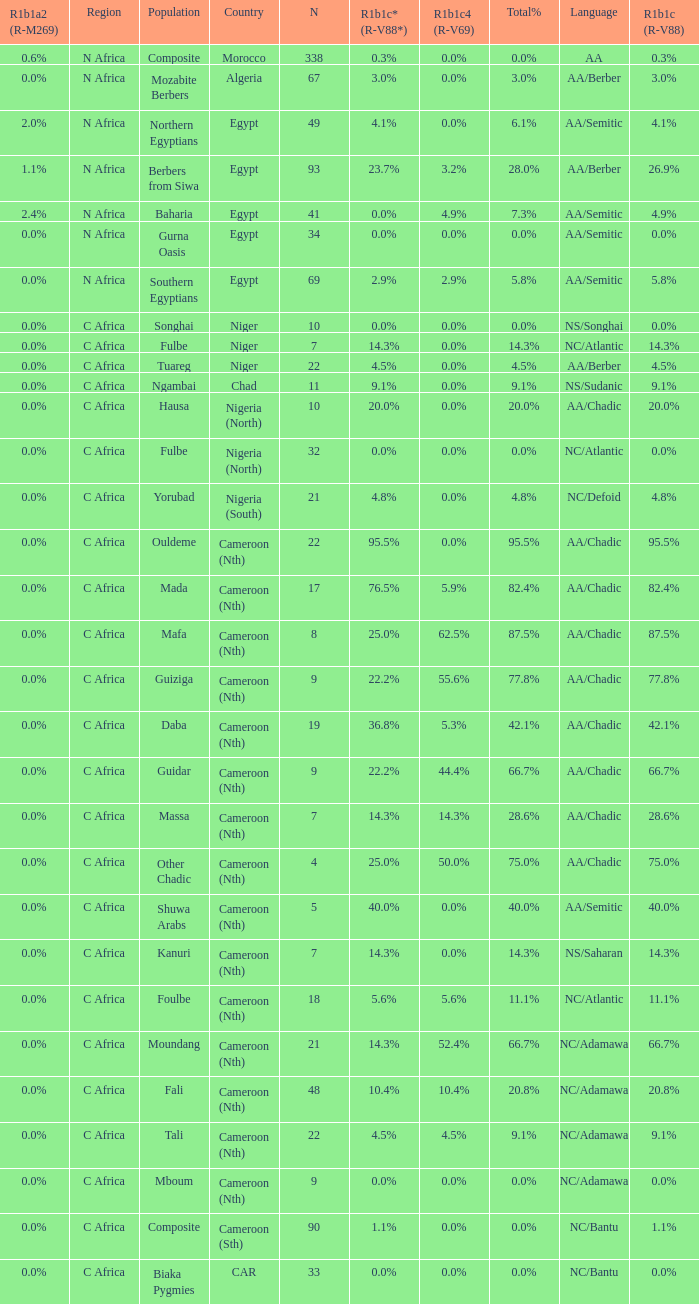Could you parse the entire table as a dict? {'header': ['R1b1a2 (R-M269)', 'Region', 'Population', 'Country', 'N', 'R1b1c* (R-V88*)', 'R1b1c4 (R-V69)', 'Total%', 'Language', 'R1b1c (R-V88)'], 'rows': [['0.6%', 'N Africa', 'Composite', 'Morocco', '338', '0.3%', '0.0%', '0.0%', 'AA', '0.3%'], ['0.0%', 'N Africa', 'Mozabite Berbers', 'Algeria', '67', '3.0%', '0.0%', '3.0%', 'AA/Berber', '3.0%'], ['2.0%', 'N Africa', 'Northern Egyptians', 'Egypt', '49', '4.1%', '0.0%', '6.1%', 'AA/Semitic', '4.1%'], ['1.1%', 'N Africa', 'Berbers from Siwa', 'Egypt', '93', '23.7%', '3.2%', '28.0%', 'AA/Berber', '26.9%'], ['2.4%', 'N Africa', 'Baharia', 'Egypt', '41', '0.0%', '4.9%', '7.3%', 'AA/Semitic', '4.9%'], ['0.0%', 'N Africa', 'Gurna Oasis', 'Egypt', '34', '0.0%', '0.0%', '0.0%', 'AA/Semitic', '0.0%'], ['0.0%', 'N Africa', 'Southern Egyptians', 'Egypt', '69', '2.9%', '2.9%', '5.8%', 'AA/Semitic', '5.8%'], ['0.0%', 'C Africa', 'Songhai', 'Niger', '10', '0.0%', '0.0%', '0.0%', 'NS/Songhai', '0.0%'], ['0.0%', 'C Africa', 'Fulbe', 'Niger', '7', '14.3%', '0.0%', '14.3%', 'NC/Atlantic', '14.3%'], ['0.0%', 'C Africa', 'Tuareg', 'Niger', '22', '4.5%', '0.0%', '4.5%', 'AA/Berber', '4.5%'], ['0.0%', 'C Africa', 'Ngambai', 'Chad', '11', '9.1%', '0.0%', '9.1%', 'NS/Sudanic', '9.1%'], ['0.0%', 'C Africa', 'Hausa', 'Nigeria (North)', '10', '20.0%', '0.0%', '20.0%', 'AA/Chadic', '20.0%'], ['0.0%', 'C Africa', 'Fulbe', 'Nigeria (North)', '32', '0.0%', '0.0%', '0.0%', 'NC/Atlantic', '0.0%'], ['0.0%', 'C Africa', 'Yorubad', 'Nigeria (South)', '21', '4.8%', '0.0%', '4.8%', 'NC/Defoid', '4.8%'], ['0.0%', 'C Africa', 'Ouldeme', 'Cameroon (Nth)', '22', '95.5%', '0.0%', '95.5%', 'AA/Chadic', '95.5%'], ['0.0%', 'C Africa', 'Mada', 'Cameroon (Nth)', '17', '76.5%', '5.9%', '82.4%', 'AA/Chadic', '82.4%'], ['0.0%', 'C Africa', 'Mafa', 'Cameroon (Nth)', '8', '25.0%', '62.5%', '87.5%', 'AA/Chadic', '87.5%'], ['0.0%', 'C Africa', 'Guiziga', 'Cameroon (Nth)', '9', '22.2%', '55.6%', '77.8%', 'AA/Chadic', '77.8%'], ['0.0%', 'C Africa', 'Daba', 'Cameroon (Nth)', '19', '36.8%', '5.3%', '42.1%', 'AA/Chadic', '42.1%'], ['0.0%', 'C Africa', 'Guidar', 'Cameroon (Nth)', '9', '22.2%', '44.4%', '66.7%', 'AA/Chadic', '66.7%'], ['0.0%', 'C Africa', 'Massa', 'Cameroon (Nth)', '7', '14.3%', '14.3%', '28.6%', 'AA/Chadic', '28.6%'], ['0.0%', 'C Africa', 'Other Chadic', 'Cameroon (Nth)', '4', '25.0%', '50.0%', '75.0%', 'AA/Chadic', '75.0%'], ['0.0%', 'C Africa', 'Shuwa Arabs', 'Cameroon (Nth)', '5', '40.0%', '0.0%', '40.0%', 'AA/Semitic', '40.0%'], ['0.0%', 'C Africa', 'Kanuri', 'Cameroon (Nth)', '7', '14.3%', '0.0%', '14.3%', 'NS/Saharan', '14.3%'], ['0.0%', 'C Africa', 'Foulbe', 'Cameroon (Nth)', '18', '5.6%', '5.6%', '11.1%', 'NC/Atlantic', '11.1%'], ['0.0%', 'C Africa', 'Moundang', 'Cameroon (Nth)', '21', '14.3%', '52.4%', '66.7%', 'NC/Adamawa', '66.7%'], ['0.0%', 'C Africa', 'Fali', 'Cameroon (Nth)', '48', '10.4%', '10.4%', '20.8%', 'NC/Adamawa', '20.8%'], ['0.0%', 'C Africa', 'Tali', 'Cameroon (Nth)', '22', '4.5%', '4.5%', '9.1%', 'NC/Adamawa', '9.1%'], ['0.0%', 'C Africa', 'Mboum', 'Cameroon (Nth)', '9', '0.0%', '0.0%', '0.0%', 'NC/Adamawa', '0.0%'], ['0.0%', 'C Africa', 'Composite', 'Cameroon (Sth)', '90', '1.1%', '0.0%', '0.0%', 'NC/Bantu', '1.1%'], ['0.0%', 'C Africa', 'Biaka Pygmies', 'CAR', '33', '0.0%', '0.0%', '0.0%', 'NC/Bantu', '0.0%']]} For 55.6% r1b1c4 (r-v69), what is the greatest n value? 9.0. 